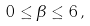<formula> <loc_0><loc_0><loc_500><loc_500>0 \leq \beta \leq 6 \, ,</formula> 